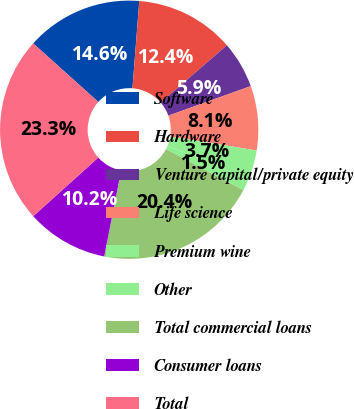Convert chart to OTSL. <chart><loc_0><loc_0><loc_500><loc_500><pie_chart><fcel>Software<fcel>Hardware<fcel>Venture capital/private equity<fcel>Life science<fcel>Premium wine<fcel>Other<fcel>Total commercial loans<fcel>Consumer loans<fcel>Total<nl><fcel>14.59%<fcel>12.41%<fcel>5.86%<fcel>8.05%<fcel>3.68%<fcel>1.5%<fcel>20.35%<fcel>10.23%<fcel>23.32%<nl></chart> 